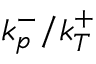Convert formula to latex. <formula><loc_0><loc_0><loc_500><loc_500>k _ { p } ^ { - } / k _ { T } ^ { + }</formula> 